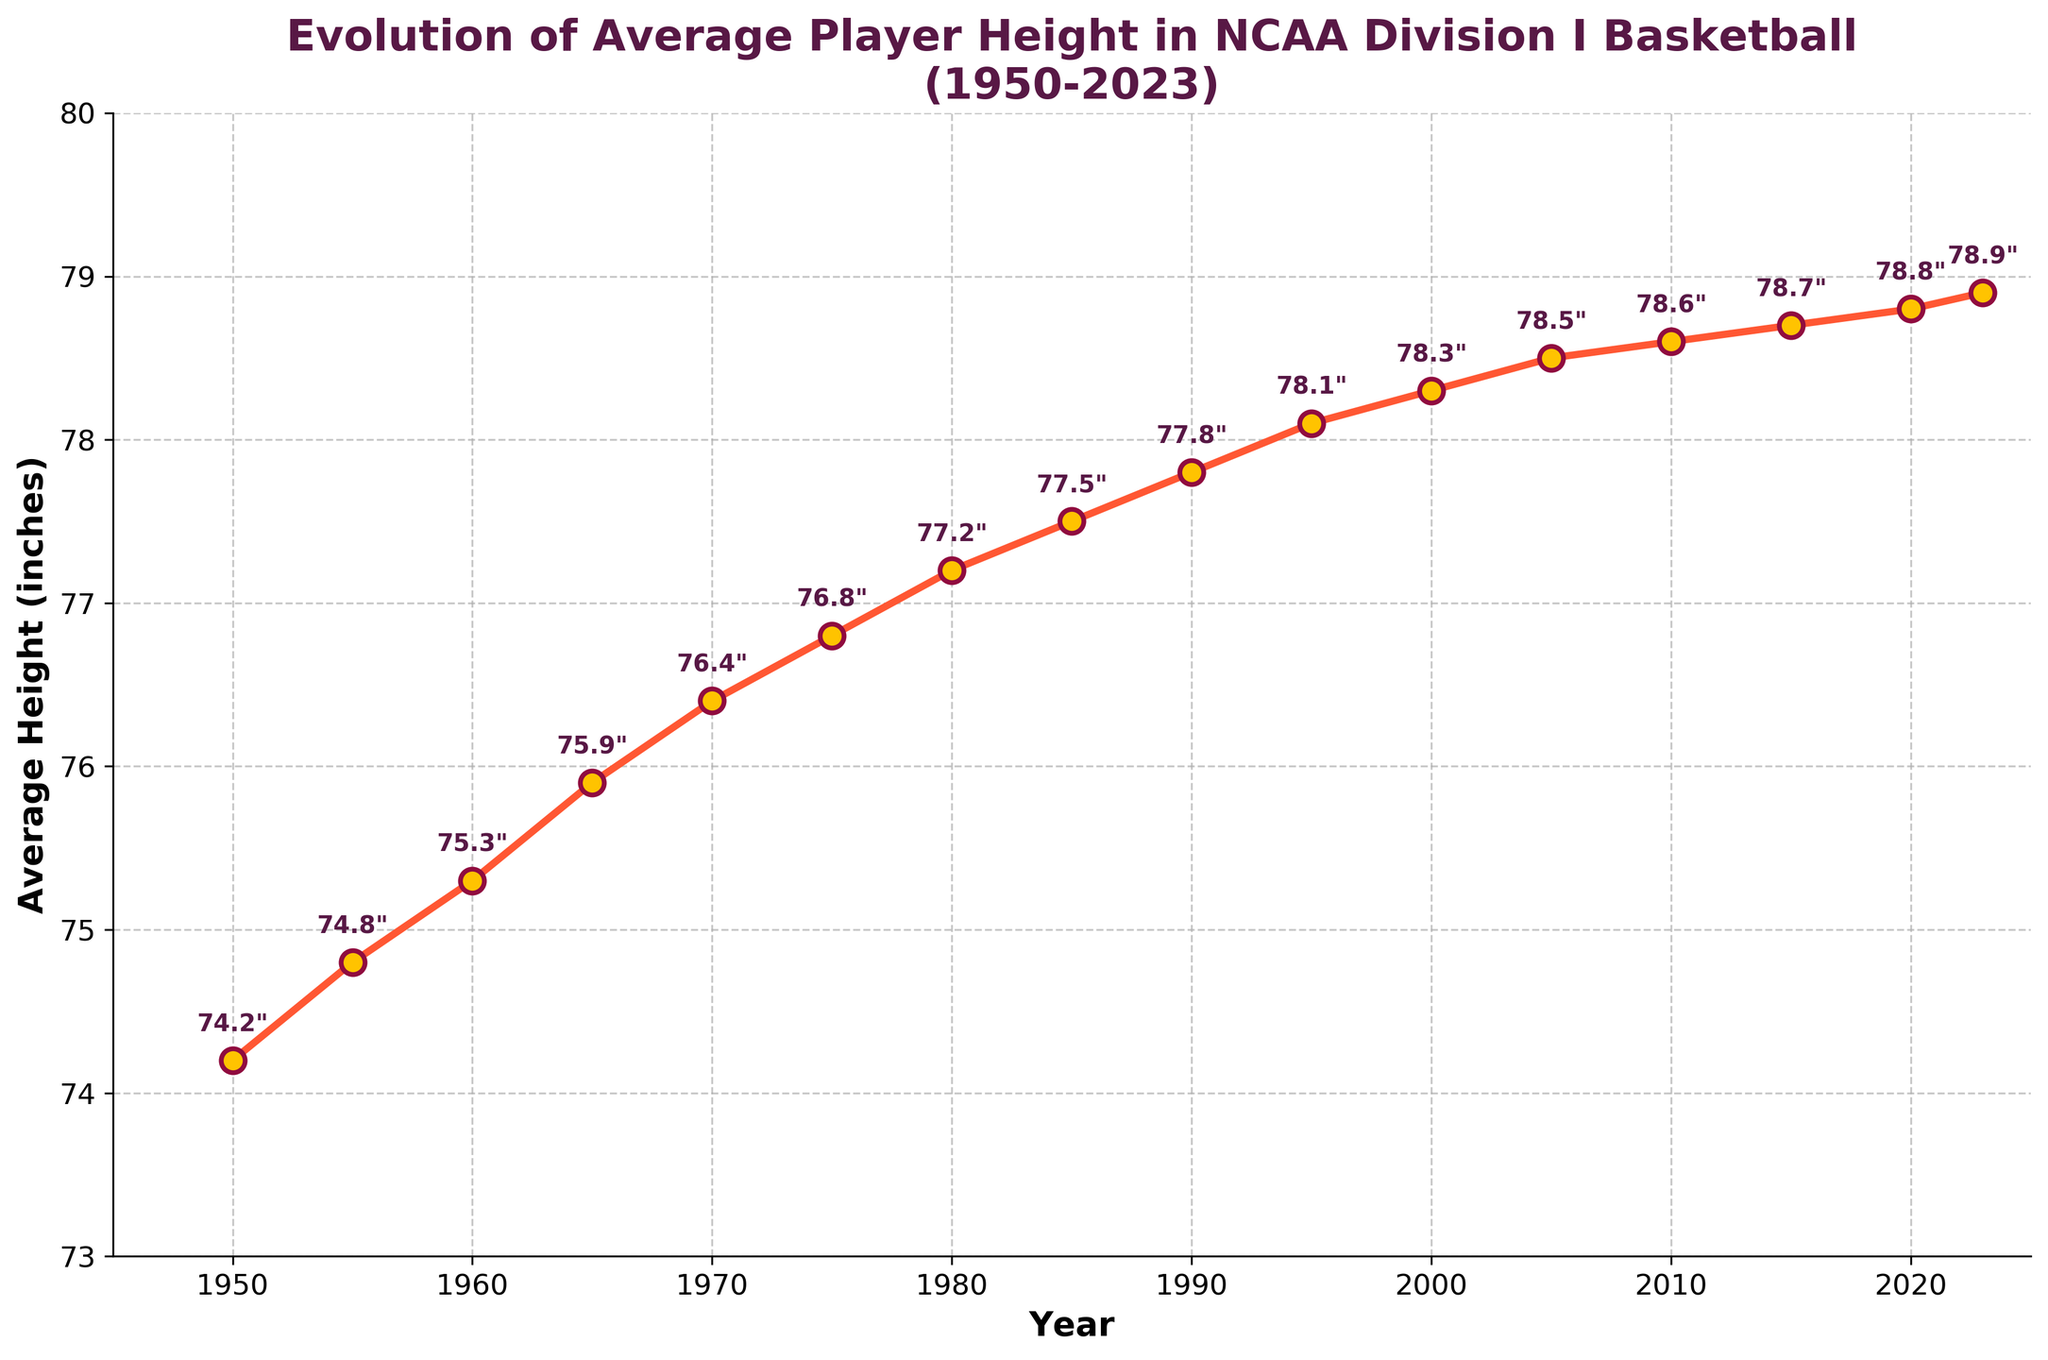What is the average height of players in 1990? The average height of players in 1990 can be directly read off the y-axis where the x-axis is 1990. The data point is marked as 77.8 inches.
Answer: 77.8 inches How much did the average height increase from 1950 to 2023? The average height in 1950 was 74.2 inches, and in 2023 it was 78.9 inches. The increase is calculated as 78.9 - 74.2.
Answer: 4.7 inches Between which two consecutive time periods did the average player height increase the most? Compare the height differences between all consecutive time periods. The largest increase is between 1960 and 1965, from 75.3 to 75.9 inches, which is an increase of 0.6 inches.
Answer: Between 1960 and 1965 What was the average player height in 2000, and how does it compare to that in 1975? The average height in 2000 was 78.3 inches and in 1975 it was 76.8 inches. The difference is 78.3 - 76.8.
Answer: In 2000, it was 1.5 inches taller than in 1975 In which decade did the average player height first exceed 78 inches? Look through the data for the point where the average height first exceeded 78 inches which is in the 1990s (1995) with a height of 78.1 inches.
Answer: 1990s Did the rate of increase in average height slow down over the years? To determine this, look at the height increments over different periods. The increases are smaller with time, e.g., from 2000 to 2023 the increase is 0.6 inches versus 1960 to 1980, which is 1.9 inches.
Answer: Yes What is the difference in average player height between the year when it was the lowest and the year when it was the highest? The lowest average height was in 1950 with 74.2 inches and the highest in 2023 with 78.9 inches. The difference is 78.9 - 74.2.
Answer: 4.7 inches What color are the markers representing data points on the line chart? The markers for the data points are yellow and have a red edge. The description mentions 'markerfacecolor' set to yellow and 'markeredgecolor' to red.
Answer: Yellow with red edges 